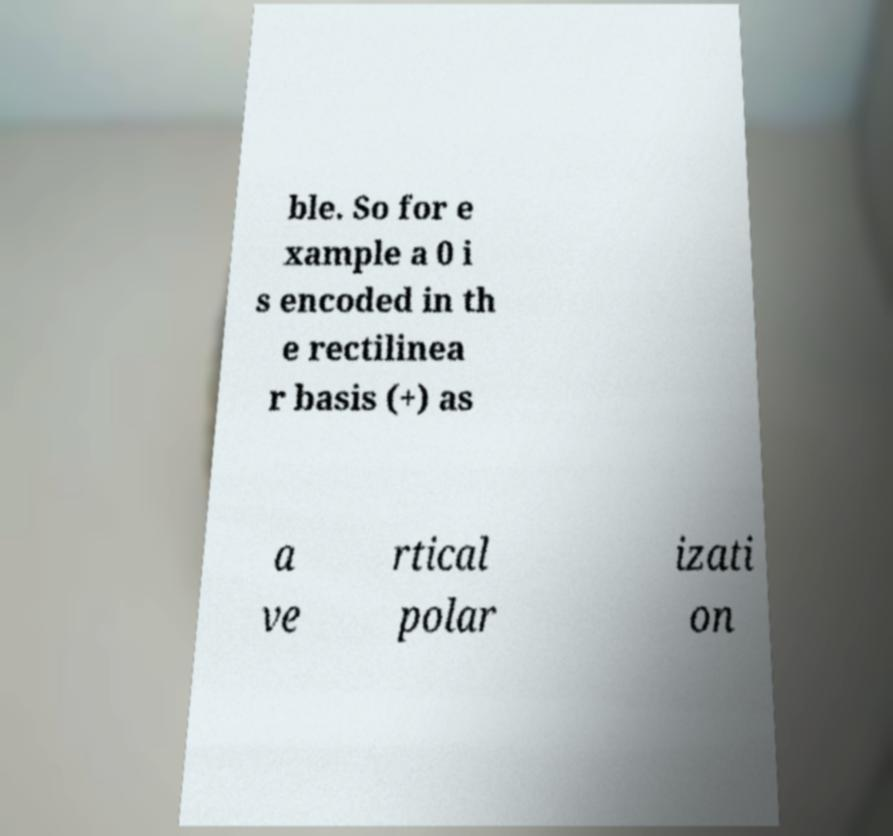There's text embedded in this image that I need extracted. Can you transcribe it verbatim? ble. So for e xample a 0 i s encoded in th e rectilinea r basis (+) as a ve rtical polar izati on 